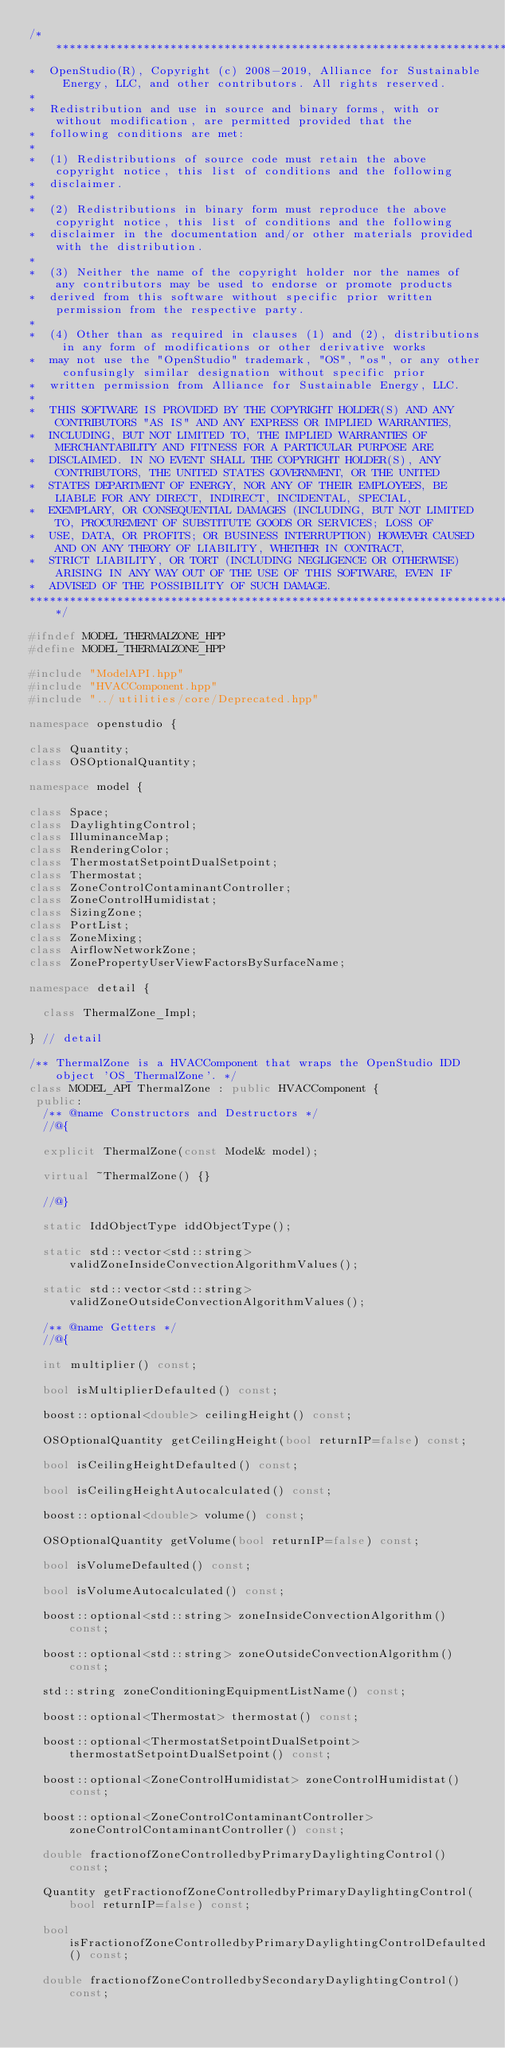Convert code to text. <code><loc_0><loc_0><loc_500><loc_500><_C++_>/***********************************************************************************************************************
*  OpenStudio(R), Copyright (c) 2008-2019, Alliance for Sustainable Energy, LLC, and other contributors. All rights reserved.
*
*  Redistribution and use in source and binary forms, with or without modification, are permitted provided that the
*  following conditions are met:
*
*  (1) Redistributions of source code must retain the above copyright notice, this list of conditions and the following
*  disclaimer.
*
*  (2) Redistributions in binary form must reproduce the above copyright notice, this list of conditions and the following
*  disclaimer in the documentation and/or other materials provided with the distribution.
*
*  (3) Neither the name of the copyright holder nor the names of any contributors may be used to endorse or promote products
*  derived from this software without specific prior written permission from the respective party.
*
*  (4) Other than as required in clauses (1) and (2), distributions in any form of modifications or other derivative works
*  may not use the "OpenStudio" trademark, "OS", "os", or any other confusingly similar designation without specific prior
*  written permission from Alliance for Sustainable Energy, LLC.
*
*  THIS SOFTWARE IS PROVIDED BY THE COPYRIGHT HOLDER(S) AND ANY CONTRIBUTORS "AS IS" AND ANY EXPRESS OR IMPLIED WARRANTIES,
*  INCLUDING, BUT NOT LIMITED TO, THE IMPLIED WARRANTIES OF MERCHANTABILITY AND FITNESS FOR A PARTICULAR PURPOSE ARE
*  DISCLAIMED. IN NO EVENT SHALL THE COPYRIGHT HOLDER(S), ANY CONTRIBUTORS, THE UNITED STATES GOVERNMENT, OR THE UNITED
*  STATES DEPARTMENT OF ENERGY, NOR ANY OF THEIR EMPLOYEES, BE LIABLE FOR ANY DIRECT, INDIRECT, INCIDENTAL, SPECIAL,
*  EXEMPLARY, OR CONSEQUENTIAL DAMAGES (INCLUDING, BUT NOT LIMITED TO, PROCUREMENT OF SUBSTITUTE GOODS OR SERVICES; LOSS OF
*  USE, DATA, OR PROFITS; OR BUSINESS INTERRUPTION) HOWEVER CAUSED AND ON ANY THEORY OF LIABILITY, WHETHER IN CONTRACT,
*  STRICT LIABILITY, OR TORT (INCLUDING NEGLIGENCE OR OTHERWISE) ARISING IN ANY WAY OUT OF THE USE OF THIS SOFTWARE, EVEN IF
*  ADVISED OF THE POSSIBILITY OF SUCH DAMAGE.
***********************************************************************************************************************/

#ifndef MODEL_THERMALZONE_HPP
#define MODEL_THERMALZONE_HPP

#include "ModelAPI.hpp"
#include "HVACComponent.hpp"
#include "../utilities/core/Deprecated.hpp"

namespace openstudio {

class Quantity;
class OSOptionalQuantity;

namespace model {

class Space;
class DaylightingControl;
class IlluminanceMap;
class RenderingColor;
class ThermostatSetpointDualSetpoint;
class Thermostat;
class ZoneControlContaminantController;
class ZoneControlHumidistat;
class SizingZone;
class PortList;
class ZoneMixing;
class AirflowNetworkZone;
class ZonePropertyUserViewFactorsBySurfaceName;

namespace detail {

  class ThermalZone_Impl;

} // detail

/** ThermalZone is a HVACComponent that wraps the OpenStudio IDD object 'OS_ThermalZone'. */
class MODEL_API ThermalZone : public HVACComponent {
 public:
  /** @name Constructors and Destructors */
  //@{

  explicit ThermalZone(const Model& model);

  virtual ~ThermalZone() {}

  //@}

  static IddObjectType iddObjectType();

  static std::vector<std::string> validZoneInsideConvectionAlgorithmValues();

  static std::vector<std::string> validZoneOutsideConvectionAlgorithmValues();

  /** @name Getters */
  //@{

  int multiplier() const;

  bool isMultiplierDefaulted() const;

  boost::optional<double> ceilingHeight() const;

  OSOptionalQuantity getCeilingHeight(bool returnIP=false) const;

  bool isCeilingHeightDefaulted() const;

  bool isCeilingHeightAutocalculated() const;

  boost::optional<double> volume() const;

  OSOptionalQuantity getVolume(bool returnIP=false) const;

  bool isVolumeDefaulted() const;

  bool isVolumeAutocalculated() const;

  boost::optional<std::string> zoneInsideConvectionAlgorithm() const;

  boost::optional<std::string> zoneOutsideConvectionAlgorithm() const;

  std::string zoneConditioningEquipmentListName() const;

  boost::optional<Thermostat> thermostat() const;

  boost::optional<ThermostatSetpointDualSetpoint> thermostatSetpointDualSetpoint() const;

  boost::optional<ZoneControlHumidistat> zoneControlHumidistat() const;

  boost::optional<ZoneControlContaminantController> zoneControlContaminantController() const;

  double fractionofZoneControlledbyPrimaryDaylightingControl() const;

  Quantity getFractionofZoneControlledbyPrimaryDaylightingControl(bool returnIP=false) const;

  bool isFractionofZoneControlledbyPrimaryDaylightingControlDefaulted() const;

  double fractionofZoneControlledbySecondaryDaylightingControl() const;
</code> 